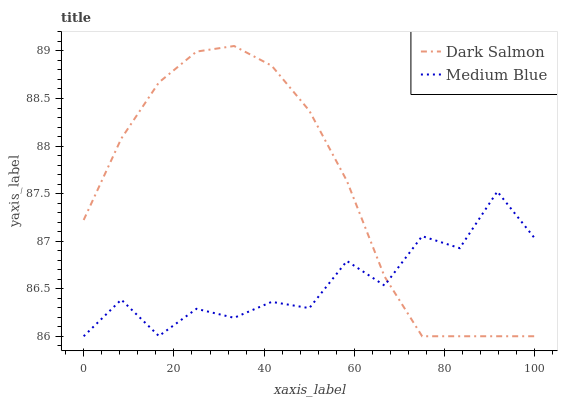Does Medium Blue have the minimum area under the curve?
Answer yes or no. Yes. Does Dark Salmon have the maximum area under the curve?
Answer yes or no. Yes. Does Dark Salmon have the minimum area under the curve?
Answer yes or no. No. Is Dark Salmon the smoothest?
Answer yes or no. Yes. Is Medium Blue the roughest?
Answer yes or no. Yes. Is Dark Salmon the roughest?
Answer yes or no. No. Does Medium Blue have the lowest value?
Answer yes or no. Yes. Does Dark Salmon have the highest value?
Answer yes or no. Yes. Does Dark Salmon intersect Medium Blue?
Answer yes or no. Yes. Is Dark Salmon less than Medium Blue?
Answer yes or no. No. Is Dark Salmon greater than Medium Blue?
Answer yes or no. No. 